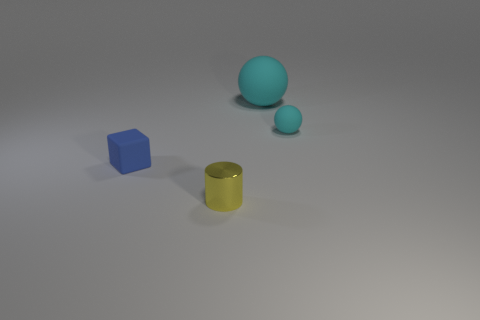Add 1 large yellow shiny spheres. How many objects exist? 5 Subtract all blocks. How many objects are left? 3 Subtract all tiny yellow rubber cylinders. Subtract all matte objects. How many objects are left? 1 Add 1 cylinders. How many cylinders are left? 2 Add 2 big gray things. How many big gray things exist? 2 Subtract 0 purple balls. How many objects are left? 4 